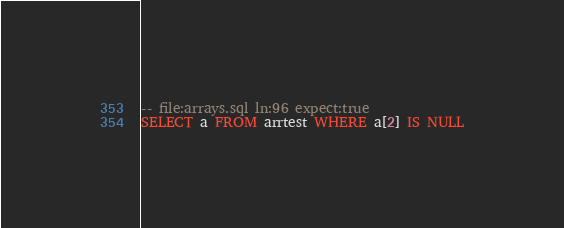Convert code to text. <code><loc_0><loc_0><loc_500><loc_500><_SQL_>-- file:arrays.sql ln:96 expect:true
SELECT a FROM arrtest WHERE a[2] IS NULL
</code> 